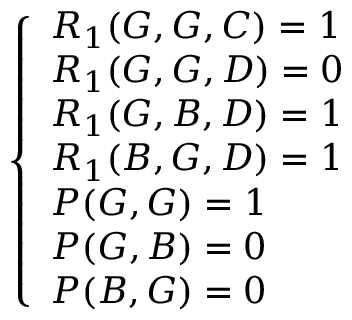<formula> <loc_0><loc_0><loc_500><loc_500>\begin{array} { r } { \left \{ \begin{array} { l l } { R _ { 1 } ( G , G , C ) = 1 } \\ { R _ { 1 } ( G , G , D ) = 0 } \\ { R _ { 1 } ( G , B , D ) = 1 } \\ { R _ { 1 } ( B , G , D ) = 1 } \\ { P ( G , G ) = 1 } \\ { P ( G , B ) = 0 } \\ { P ( B , G ) = 0 } \end{array} } \end{array}</formula> 